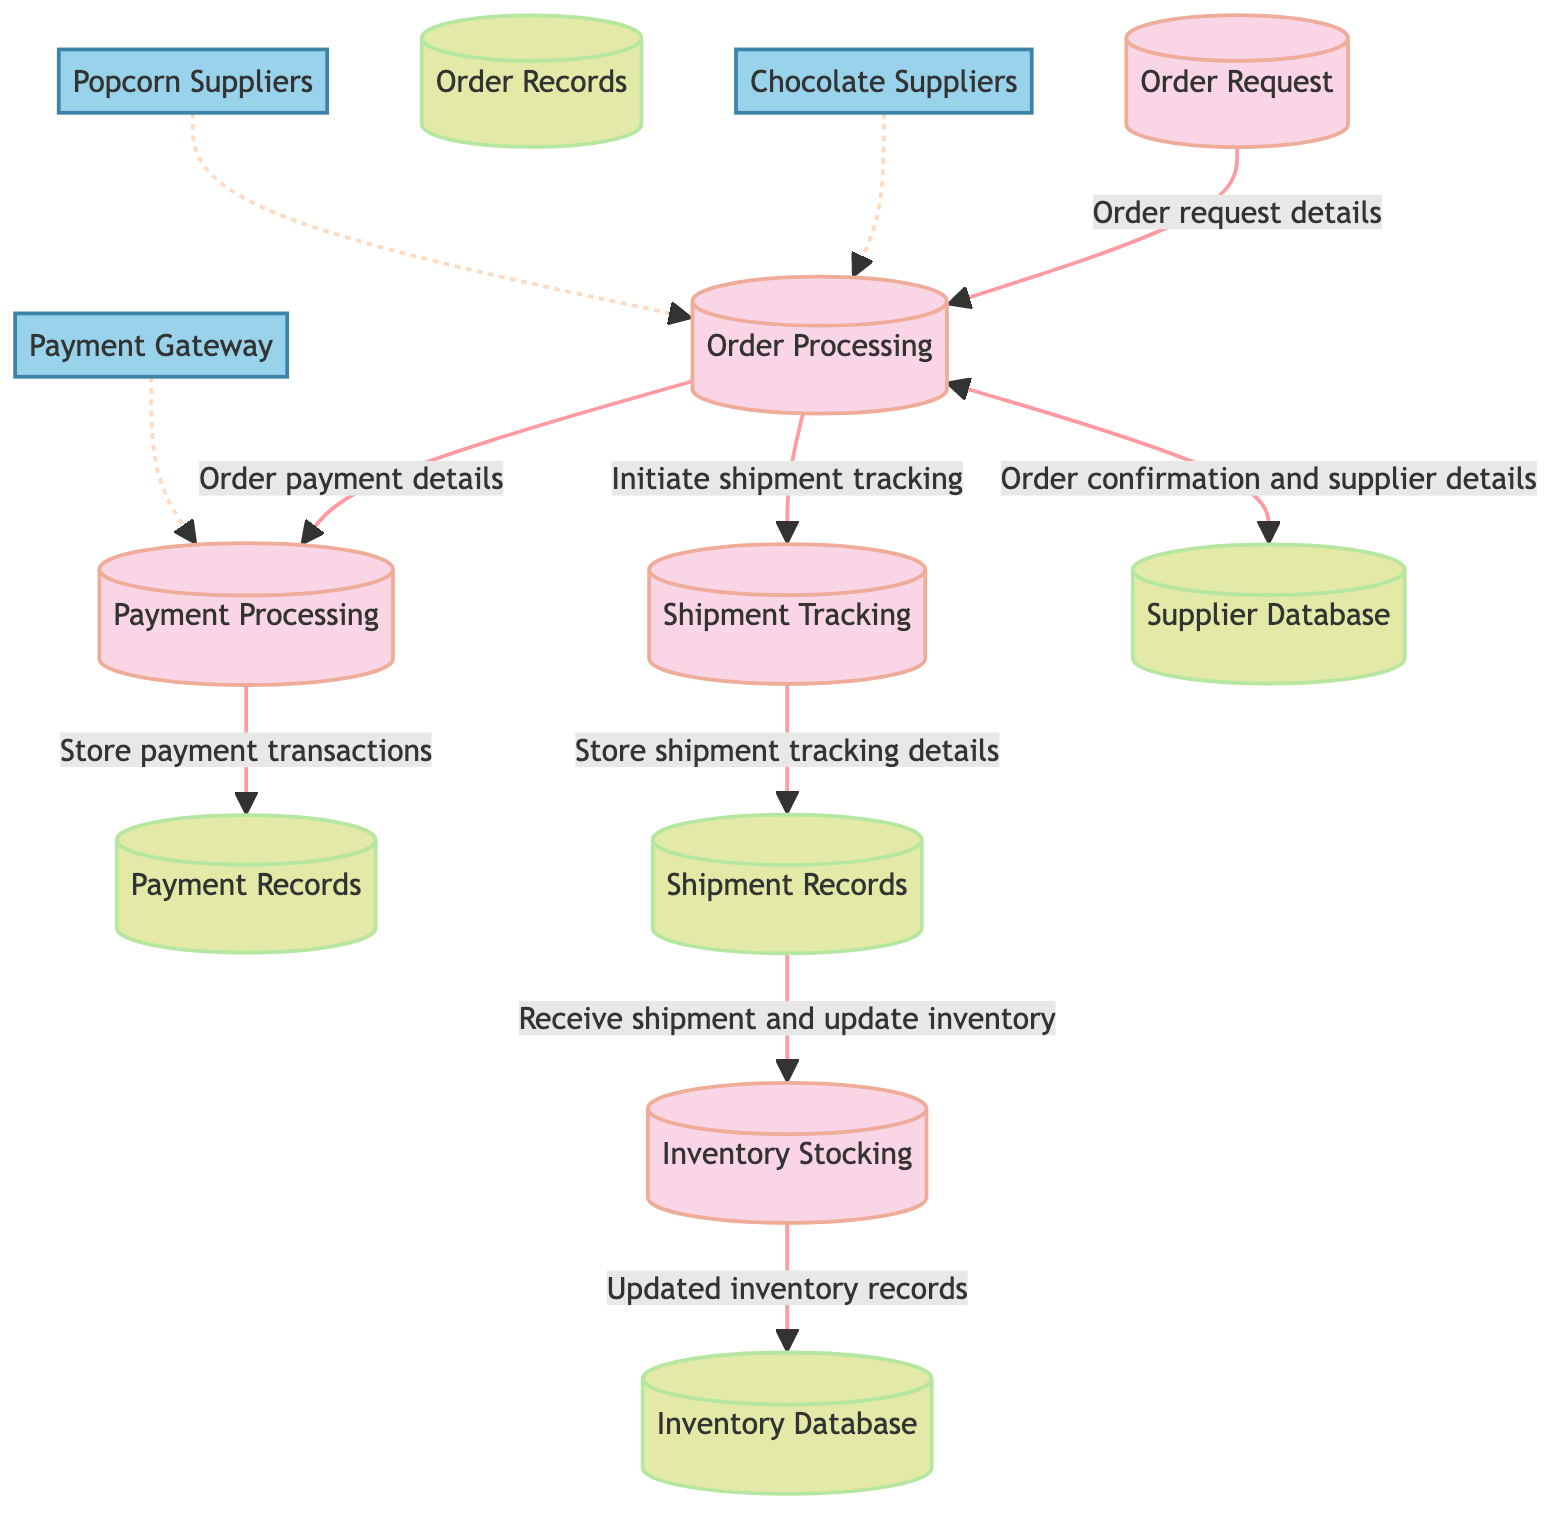What is the first process in the diagram? The diagram indicates that the first process is "Order Request," which is labeled as P1. It's the starting point where the request is received from the shop to place an order with a supplier.
Answer: Order Request How many data stores are shown in the diagram? The diagram displays a total of five data stores: Supplier Database, Order Records, Payment Records, Shipment Records, and Inventory Database.
Answer: Five Which external entity provides payment transactions? The external entity responsible for managing payment transactions is labeled as "Payment Gateway" in the diagram.
Answer: Payment Gateway What process is directly related to shipment tracking? The "Shipment Tracking" process, labeled as P4, is directly associated with the retrieval and monitoring of shipment details.
Answer: Shipment Tracking What does the flow from Order Processing to Shipment Tracking represent? The flow from "Order Processing" to "Shipment Tracking" indicates the initiation of shipment tracking after the order has been confirmed and is ready for dispatch.
Answer: Initiate shipment tracking What type of information does the Payment Processing flow to Payment Records carry? The flow from "Payment Processing" to "Payment Records" carries details about payment transactions, indicating that the payment information is stored in the records.
Answer: Store payment transactions How many external entities are connected to the Order Processing process? There are three external entities connected to the "Order Processing" process, specifically "Chocolate Suppliers," "Popcorn Suppliers," and "Payment Gateway."
Answer: Three What action is triggered by receiving shipment details in the Shipment Tracking process? Upon receiving shipment details, the "Shipment Tracking" process updates the "Shipment Records," indicating that tracking information is documented to monitor shipment status.
Answer: Store shipment tracking details What does the Inventory Stocking process do after receiving shipment data? The "Inventory Stocking" process updates the inventory records in the "Inventory Database" upon receiving shipment data, ensuring the shop's inventory is current.
Answer: Updated inventory records 